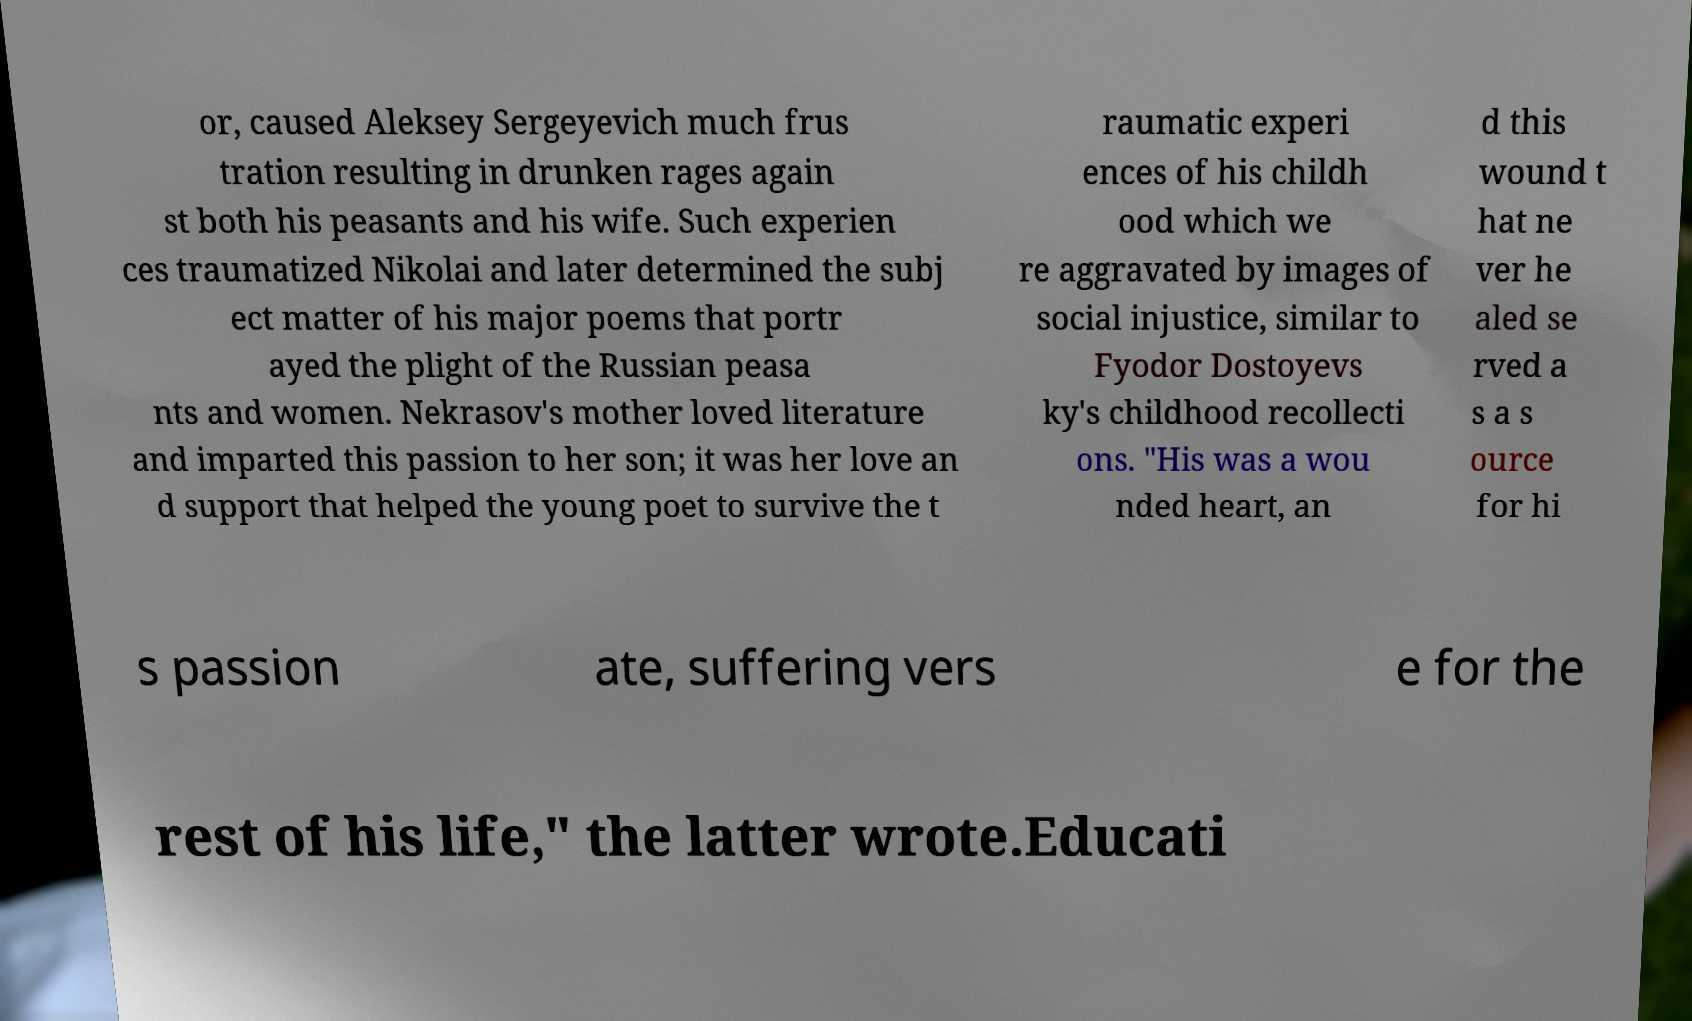For documentation purposes, I need the text within this image transcribed. Could you provide that? or, caused Aleksey Sergeyevich much frus tration resulting in drunken rages again st both his peasants and his wife. Such experien ces traumatized Nikolai and later determined the subj ect matter of his major poems that portr ayed the plight of the Russian peasa nts and women. Nekrasov's mother loved literature and imparted this passion to her son; it was her love an d support that helped the young poet to survive the t raumatic experi ences of his childh ood which we re aggravated by images of social injustice, similar to Fyodor Dostoyevs ky's childhood recollecti ons. "His was a wou nded heart, an d this wound t hat ne ver he aled se rved a s a s ource for hi s passion ate, suffering vers e for the rest of his life," the latter wrote.Educati 